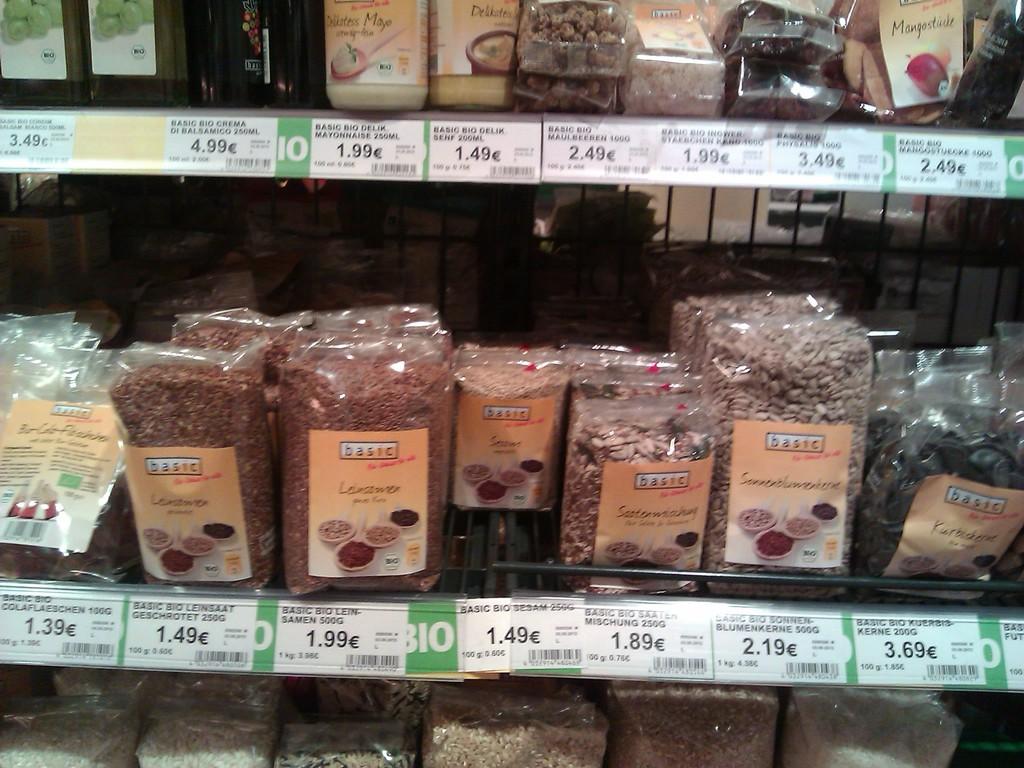How much does 500g of samen cost?
Keep it short and to the point. 1.99. 